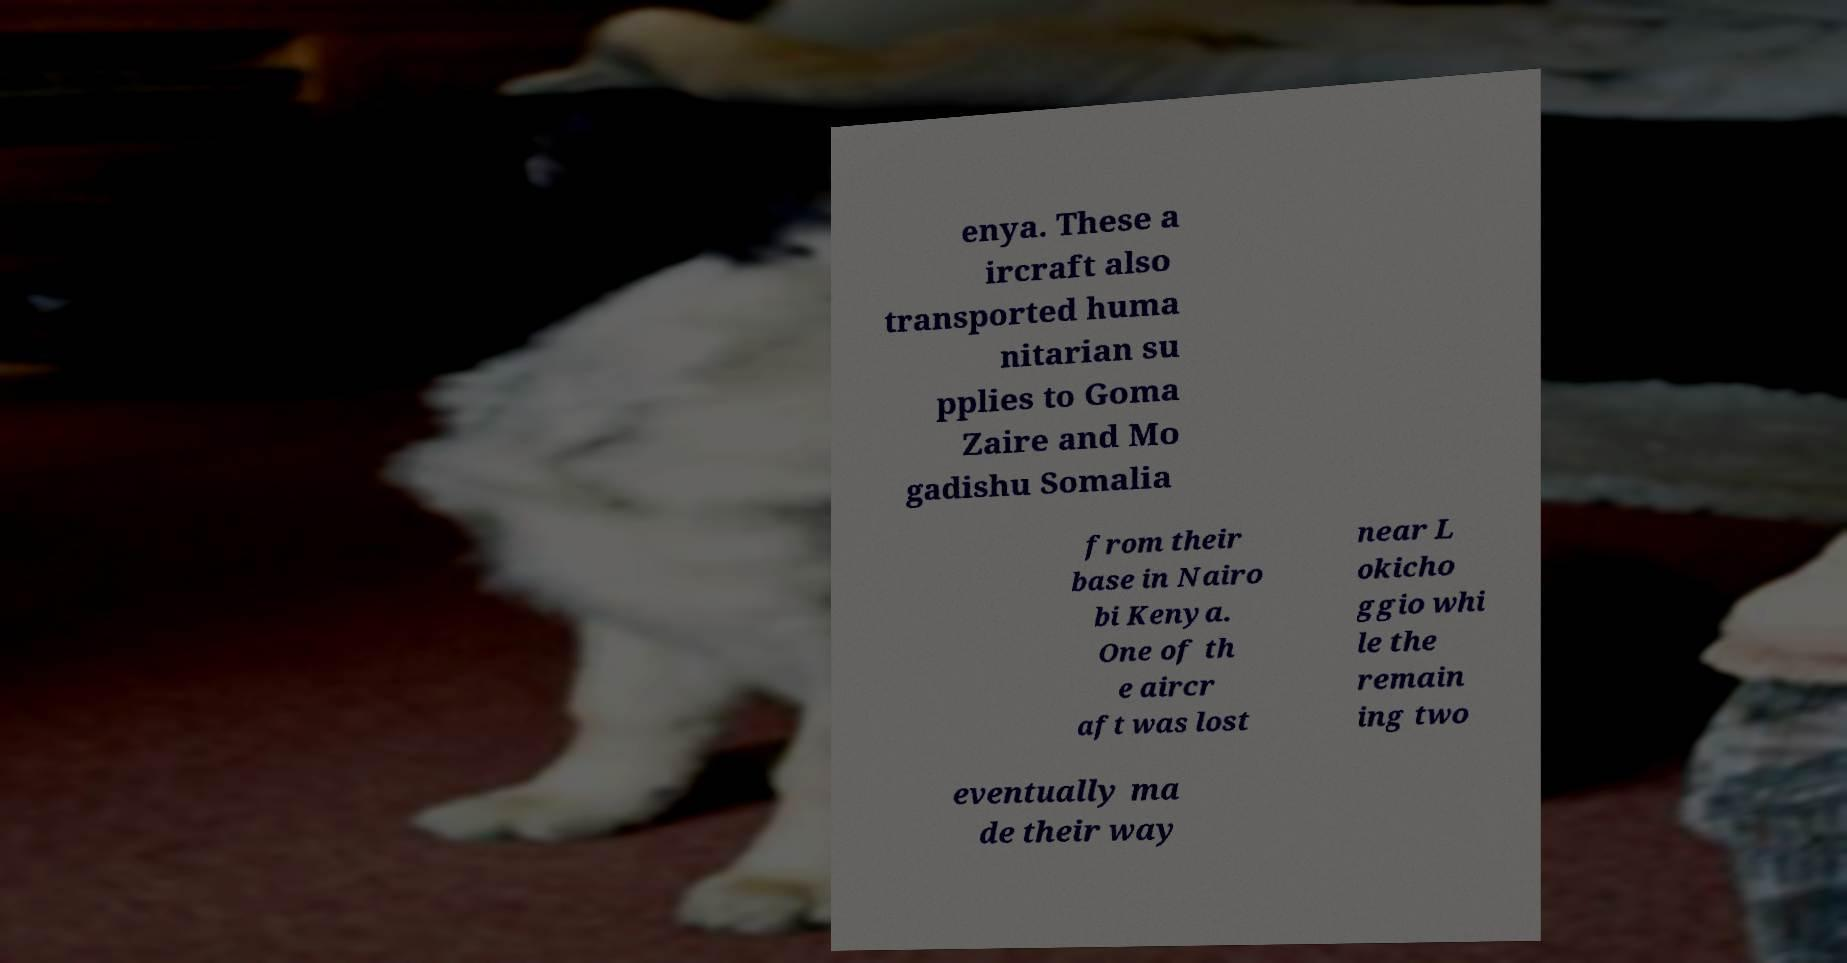What messages or text are displayed in this image? I need them in a readable, typed format. enya. These a ircraft also transported huma nitarian su pplies to Goma Zaire and Mo gadishu Somalia from their base in Nairo bi Kenya. One of th e aircr aft was lost near L okicho ggio whi le the remain ing two eventually ma de their way 